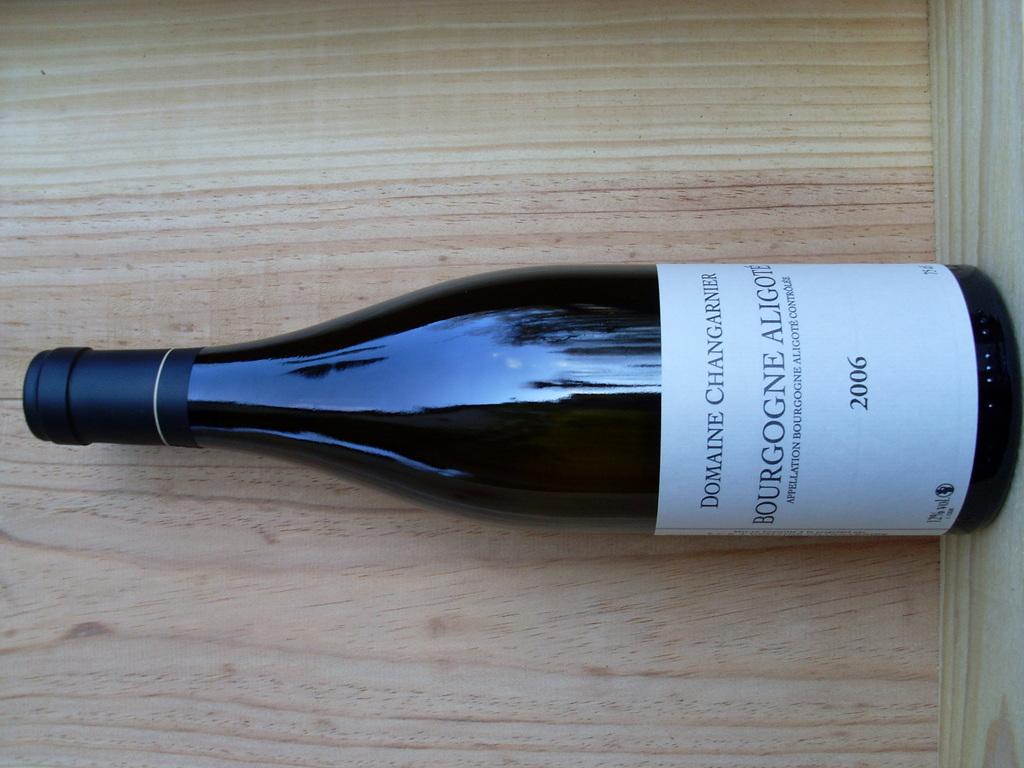What type of drink is inside this bottle?
Your response must be concise. Wine. What year was this drink made?
Your answer should be compact. 2006. 